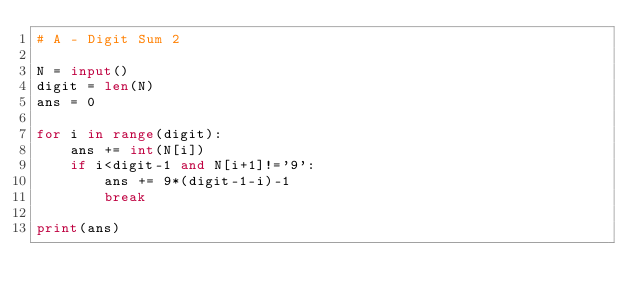Convert code to text. <code><loc_0><loc_0><loc_500><loc_500><_Python_># A - Digit Sum 2

N = input()
digit = len(N)
ans = 0

for i in range(digit):
    ans += int(N[i])
    if i<digit-1 and N[i+1]!='9':
        ans += 9*(digit-1-i)-1
        break

print(ans)</code> 